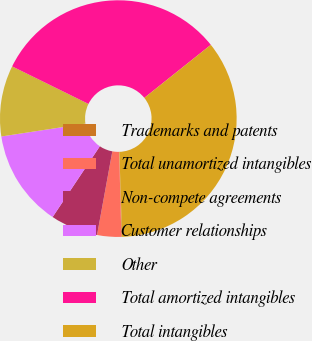<chart> <loc_0><loc_0><loc_500><loc_500><pie_chart><fcel>Trademarks and patents<fcel>Total unamortized intangibles<fcel>Non-compete agreements<fcel>Customer relationships<fcel>Other<fcel>Total amortized intangibles<fcel>Total intangibles<nl><fcel>0.09%<fcel>3.29%<fcel>6.49%<fcel>13.22%<fcel>9.69%<fcel>32.01%<fcel>35.21%<nl></chart> 